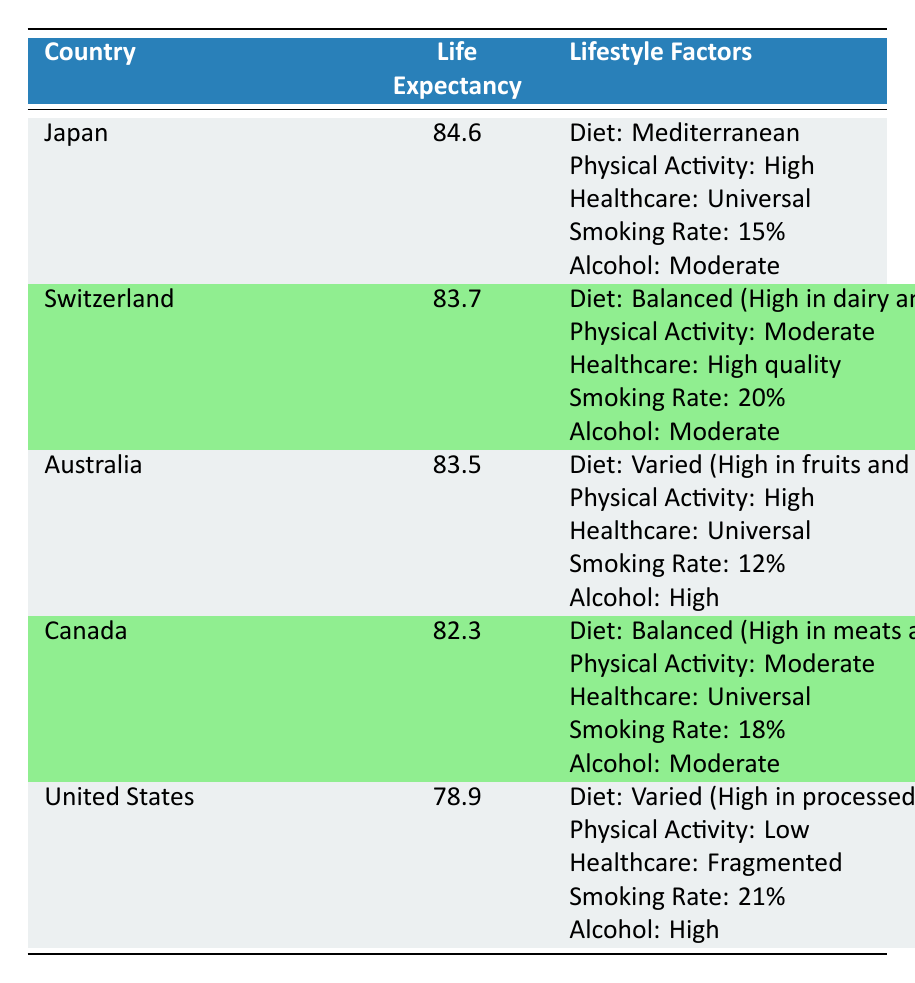What is the life expectancy at birth in Japan? According to the table, the life expectancy at birth for Japan is explicitly stated as 84.6 years.
Answer: 84.6 Which country has the lowest life expectancy at birth? The table lists the United States with a life expectancy at birth of 78.9 years, which is the lowest among the given countries.
Answer: United States How many countries have a high physical activity level? By checking the table, Japan and Australia both mention "High" for physical activity, totaling 2 countries with this attribute.
Answer: 2 What is the average life expectancy at birth for countries with universal healthcare access? The countries with universal healthcare access are Japan, Australia, and Canada, with life expectancies of 84.6, 83.5, and 82.3 respectively. The average is calculated as (84.6 + 83.5 + 82.3) / 3 = 83.47.
Answer: 83.47 Is the smoking rate higher in Australia than in Canada? Based on the table, Australia's smoking rate is 12%, while Canada's is 18%. Since 12% is not higher than 18%, the answer is no.
Answer: No What is the difference in life expectancy at birth between Japan and the United States? Japan's life expectancy at birth is 84.6 years and the United States is 78.9 years. The difference is calculated as 84.6 - 78.9 = 5.7 years.
Answer: 5.7 Does Switzerland have a higher smoking rate than Japan? Referring to the table, Switzerland's smoking rate is 20%, while Japan's smoking rate is 15%. Since 20% is greater than 15%, the answer is yes.
Answer: Yes Which country has a balanced diet and what is its life expectancy at birth? The table indicates that Switzerland has a balanced diet and its life expectancy at birth is 83.7 years.
Answer: Switzerland, 83.7 What lifestyle factor is shared by Australia and Japan? Both countries feature high levels of physical activity in their lifestyle factors according to the table.
Answer: High physical activity 